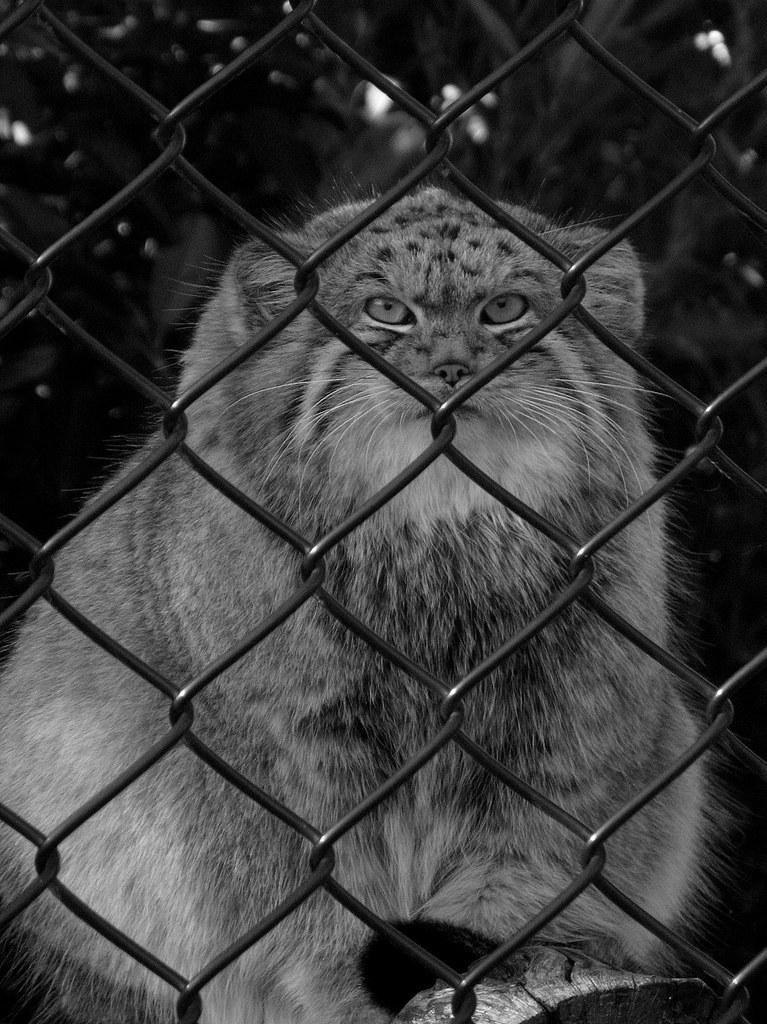What is the color scheme of the image? The image is black and white. What type of material or structure can be seen in the image? There is a mesh in the image. What is located behind the mesh? There is a cat behind the mesh. How many children are visible in the image? There are no children present in the image; it features a cat behind a mesh in a black and white setting. What type of fuel is being used by the airplane in the image? There is no airplane present in the image, so it is not possible to determine what type of fuel it might be using. 